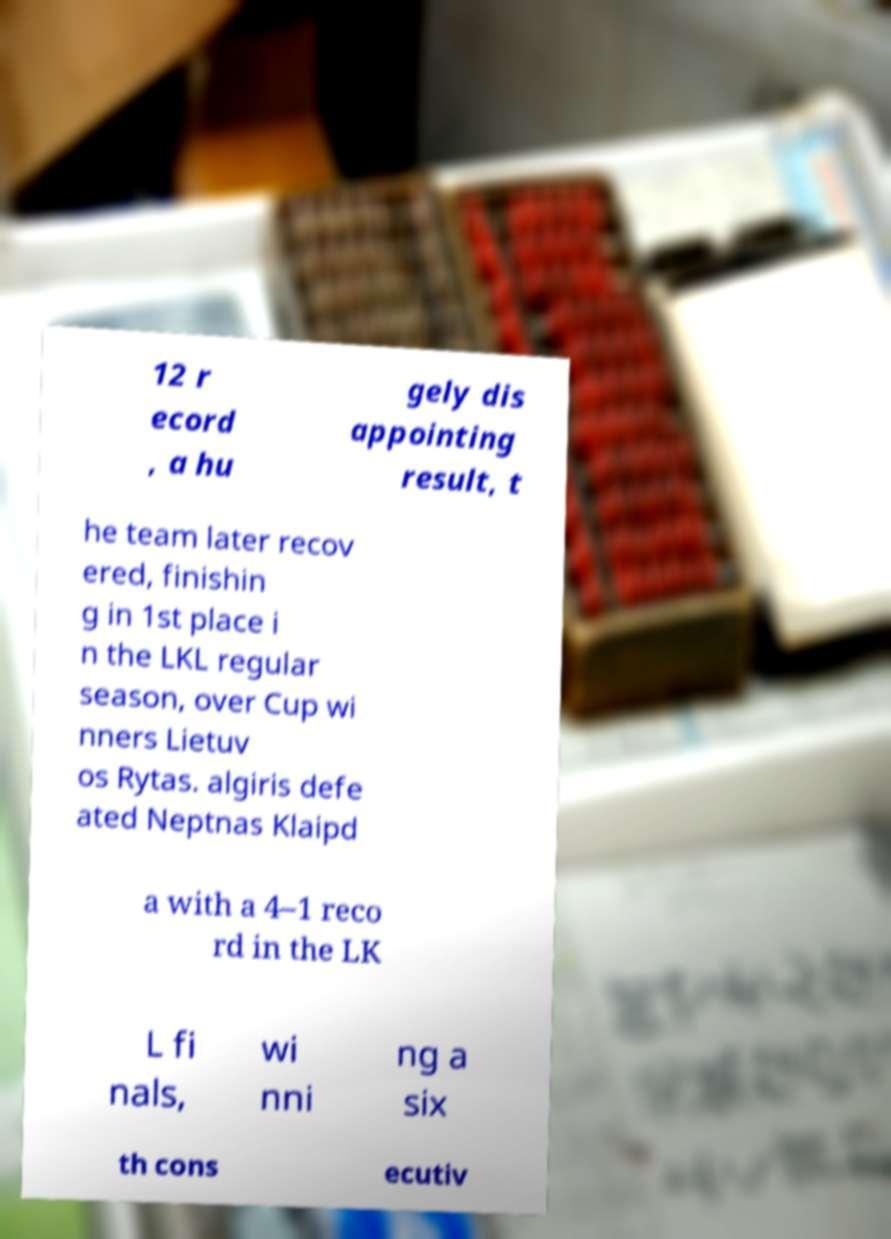Please read and relay the text visible in this image. What does it say? 12 r ecord , a hu gely dis appointing result, t he team later recov ered, finishin g in 1st place i n the LKL regular season, over Cup wi nners Lietuv os Rytas. algiris defe ated Neptnas Klaipd a with a 4–1 reco rd in the LK L fi nals, wi nni ng a six th cons ecutiv 